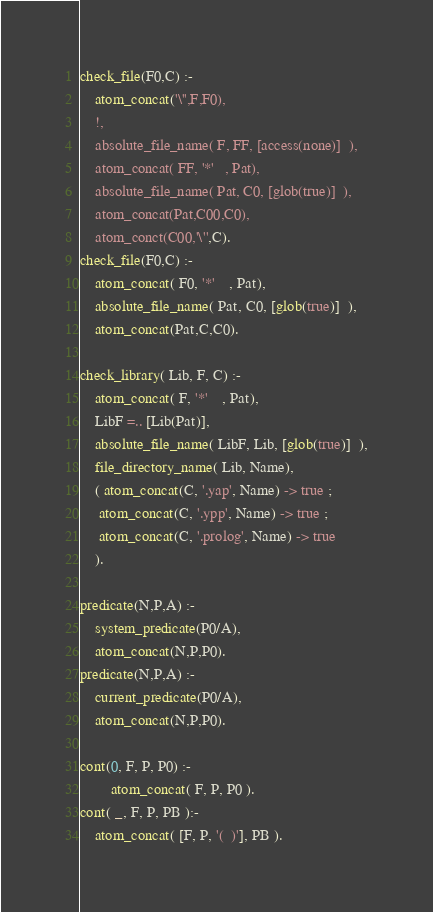<code> <loc_0><loc_0><loc_500><loc_500><_Prolog_>check_file(F0,C) :-
	atom_concat('\'',F,F0),
	!,
	absolute_file_name( F, FF, [access(none)]  ),
	atom_concat( FF, '*'	, Pat),
	absolute_file_name( Pat, C0, [glob(true)]  ),
	atom_concat(Pat,C00,C0),
	atom_conct(C00,'\'',C).
check_file(F0,C) :-
	atom_concat( F0, '*'	, Pat),
	absolute_file_name( Pat, C0, [glob(true)]  ),
	atom_concat(Pat,C,C0).

check_library( Lib, F, C) :-
	atom_concat( F, '*'	, Pat),
	LibF =.. [Lib(Pat)],
	absolute_file_name( LibF, Lib, [glob(true)]  ),
	file_directory_name( Lib, Name),
	( atom_concat(C, '.yap', Name) -> true ;
	 atom_concat(C, '.ypp', Name) -> true ;
	 atom_concat(C, '.prolog', Name) -> true
	).

predicate(N,P,A) :-
	system_predicate(P0/A),
	atom_concat(N,P,P0).
predicate(N,P,A) :-
	current_predicate(P0/A),
	atom_concat(N,P,P0).

cont(0, F, P, P0) :-
		atom_concat( F, P, P0 ).
cont( _, F, P, PB ):-
	atom_concat( [F, P, '(  )'], PB ).





</code> 